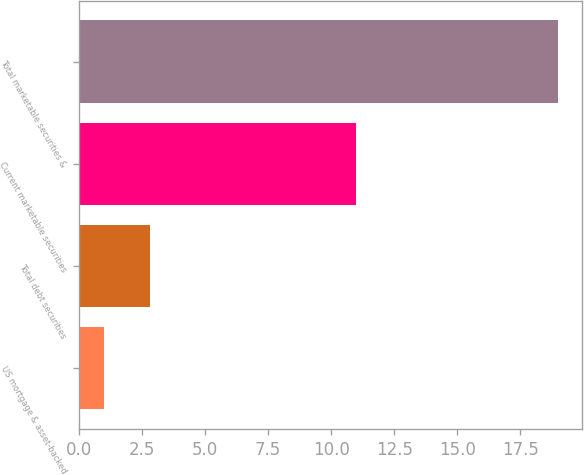Convert chart. <chart><loc_0><loc_0><loc_500><loc_500><bar_chart><fcel>US mortgage & asset-backed<fcel>Total debt securities<fcel>Current marketable securities<fcel>Total marketable securities &<nl><fcel>1<fcel>2.8<fcel>11<fcel>19<nl></chart> 